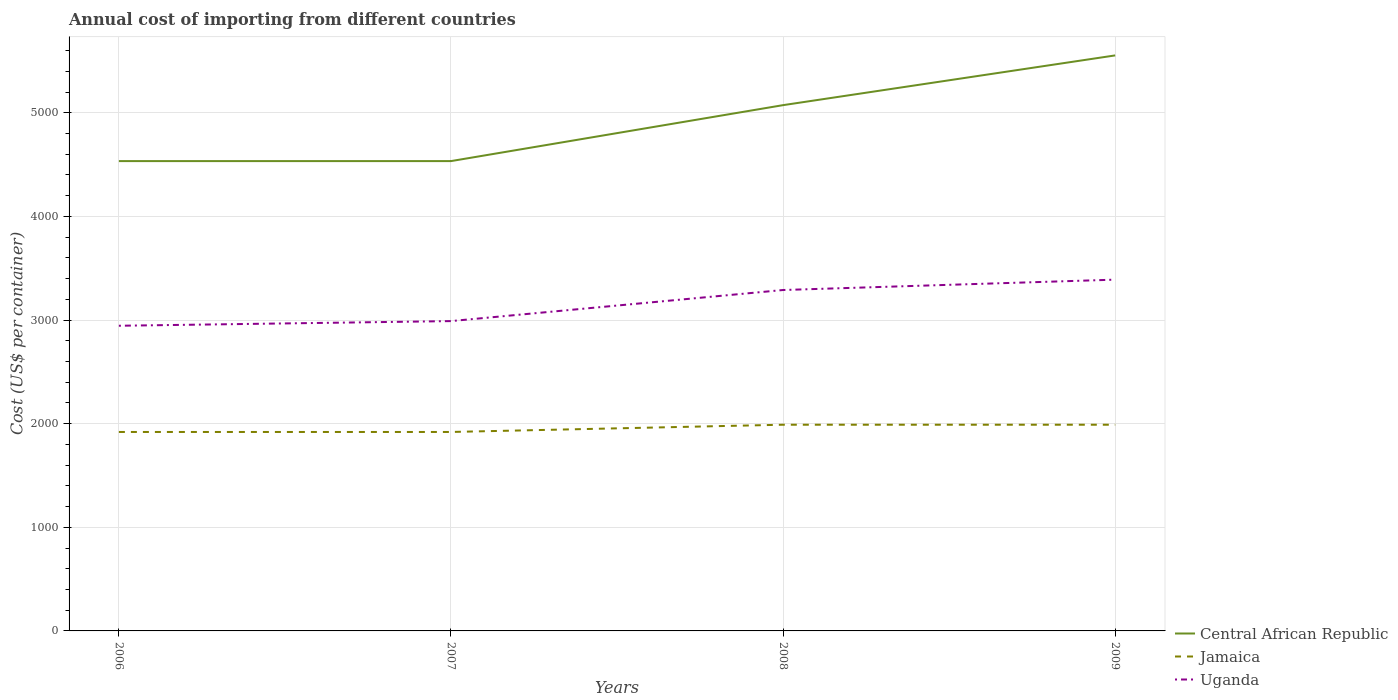Does the line corresponding to Central African Republic intersect with the line corresponding to Uganda?
Offer a terse response. No. Is the number of lines equal to the number of legend labels?
Give a very brief answer. Yes. Across all years, what is the maximum total annual cost of importing in Central African Republic?
Your answer should be very brief. 4534. What is the total total annual cost of importing in Jamaica in the graph?
Your answer should be compact. -70. What is the difference between the highest and the second highest total annual cost of importing in Uganda?
Your answer should be compact. 445. What is the difference between the highest and the lowest total annual cost of importing in Jamaica?
Offer a terse response. 2. Is the total annual cost of importing in Jamaica strictly greater than the total annual cost of importing in Uganda over the years?
Your answer should be compact. Yes. How many years are there in the graph?
Your response must be concise. 4. Does the graph contain grids?
Give a very brief answer. Yes. Where does the legend appear in the graph?
Provide a short and direct response. Bottom right. How many legend labels are there?
Make the answer very short. 3. What is the title of the graph?
Your response must be concise. Annual cost of importing from different countries. What is the label or title of the Y-axis?
Give a very brief answer. Cost (US$ per container). What is the Cost (US$ per container) of Central African Republic in 2006?
Give a very brief answer. 4534. What is the Cost (US$ per container) in Jamaica in 2006?
Give a very brief answer. 1920. What is the Cost (US$ per container) of Uganda in 2006?
Give a very brief answer. 2945. What is the Cost (US$ per container) of Central African Republic in 2007?
Give a very brief answer. 4534. What is the Cost (US$ per container) of Jamaica in 2007?
Your answer should be very brief. 1920. What is the Cost (US$ per container) in Uganda in 2007?
Keep it short and to the point. 2990. What is the Cost (US$ per container) of Central African Republic in 2008?
Keep it short and to the point. 5074. What is the Cost (US$ per container) of Jamaica in 2008?
Make the answer very short. 1990. What is the Cost (US$ per container) of Uganda in 2008?
Offer a terse response. 3290. What is the Cost (US$ per container) in Central African Republic in 2009?
Keep it short and to the point. 5554. What is the Cost (US$ per container) of Jamaica in 2009?
Offer a very short reply. 1990. What is the Cost (US$ per container) in Uganda in 2009?
Provide a short and direct response. 3390. Across all years, what is the maximum Cost (US$ per container) of Central African Republic?
Offer a terse response. 5554. Across all years, what is the maximum Cost (US$ per container) of Jamaica?
Your answer should be compact. 1990. Across all years, what is the maximum Cost (US$ per container) of Uganda?
Keep it short and to the point. 3390. Across all years, what is the minimum Cost (US$ per container) of Central African Republic?
Your response must be concise. 4534. Across all years, what is the minimum Cost (US$ per container) in Jamaica?
Provide a short and direct response. 1920. Across all years, what is the minimum Cost (US$ per container) of Uganda?
Offer a very short reply. 2945. What is the total Cost (US$ per container) in Central African Republic in the graph?
Your response must be concise. 1.97e+04. What is the total Cost (US$ per container) of Jamaica in the graph?
Offer a very short reply. 7820. What is the total Cost (US$ per container) of Uganda in the graph?
Make the answer very short. 1.26e+04. What is the difference between the Cost (US$ per container) of Jamaica in 2006 and that in 2007?
Offer a very short reply. 0. What is the difference between the Cost (US$ per container) in Uganda in 2006 and that in 2007?
Your answer should be compact. -45. What is the difference between the Cost (US$ per container) of Central African Republic in 2006 and that in 2008?
Your response must be concise. -540. What is the difference between the Cost (US$ per container) of Jamaica in 2006 and that in 2008?
Ensure brevity in your answer.  -70. What is the difference between the Cost (US$ per container) in Uganda in 2006 and that in 2008?
Your response must be concise. -345. What is the difference between the Cost (US$ per container) of Central African Republic in 2006 and that in 2009?
Give a very brief answer. -1020. What is the difference between the Cost (US$ per container) of Jamaica in 2006 and that in 2009?
Give a very brief answer. -70. What is the difference between the Cost (US$ per container) of Uganda in 2006 and that in 2009?
Provide a short and direct response. -445. What is the difference between the Cost (US$ per container) in Central African Republic in 2007 and that in 2008?
Give a very brief answer. -540. What is the difference between the Cost (US$ per container) in Jamaica in 2007 and that in 2008?
Your response must be concise. -70. What is the difference between the Cost (US$ per container) of Uganda in 2007 and that in 2008?
Provide a succinct answer. -300. What is the difference between the Cost (US$ per container) in Central African Republic in 2007 and that in 2009?
Give a very brief answer. -1020. What is the difference between the Cost (US$ per container) of Jamaica in 2007 and that in 2009?
Your answer should be very brief. -70. What is the difference between the Cost (US$ per container) in Uganda in 2007 and that in 2009?
Ensure brevity in your answer.  -400. What is the difference between the Cost (US$ per container) in Central African Republic in 2008 and that in 2009?
Ensure brevity in your answer.  -480. What is the difference between the Cost (US$ per container) in Jamaica in 2008 and that in 2009?
Your answer should be compact. 0. What is the difference between the Cost (US$ per container) in Uganda in 2008 and that in 2009?
Keep it short and to the point. -100. What is the difference between the Cost (US$ per container) of Central African Republic in 2006 and the Cost (US$ per container) of Jamaica in 2007?
Your answer should be very brief. 2614. What is the difference between the Cost (US$ per container) of Central African Republic in 2006 and the Cost (US$ per container) of Uganda in 2007?
Ensure brevity in your answer.  1544. What is the difference between the Cost (US$ per container) of Jamaica in 2006 and the Cost (US$ per container) of Uganda in 2007?
Your answer should be compact. -1070. What is the difference between the Cost (US$ per container) of Central African Republic in 2006 and the Cost (US$ per container) of Jamaica in 2008?
Provide a short and direct response. 2544. What is the difference between the Cost (US$ per container) of Central African Republic in 2006 and the Cost (US$ per container) of Uganda in 2008?
Your response must be concise. 1244. What is the difference between the Cost (US$ per container) in Jamaica in 2006 and the Cost (US$ per container) in Uganda in 2008?
Provide a short and direct response. -1370. What is the difference between the Cost (US$ per container) of Central African Republic in 2006 and the Cost (US$ per container) of Jamaica in 2009?
Provide a succinct answer. 2544. What is the difference between the Cost (US$ per container) in Central African Republic in 2006 and the Cost (US$ per container) in Uganda in 2009?
Offer a terse response. 1144. What is the difference between the Cost (US$ per container) in Jamaica in 2006 and the Cost (US$ per container) in Uganda in 2009?
Offer a very short reply. -1470. What is the difference between the Cost (US$ per container) of Central African Republic in 2007 and the Cost (US$ per container) of Jamaica in 2008?
Offer a terse response. 2544. What is the difference between the Cost (US$ per container) of Central African Republic in 2007 and the Cost (US$ per container) of Uganda in 2008?
Keep it short and to the point. 1244. What is the difference between the Cost (US$ per container) of Jamaica in 2007 and the Cost (US$ per container) of Uganda in 2008?
Keep it short and to the point. -1370. What is the difference between the Cost (US$ per container) of Central African Republic in 2007 and the Cost (US$ per container) of Jamaica in 2009?
Offer a very short reply. 2544. What is the difference between the Cost (US$ per container) of Central African Republic in 2007 and the Cost (US$ per container) of Uganda in 2009?
Keep it short and to the point. 1144. What is the difference between the Cost (US$ per container) of Jamaica in 2007 and the Cost (US$ per container) of Uganda in 2009?
Give a very brief answer. -1470. What is the difference between the Cost (US$ per container) of Central African Republic in 2008 and the Cost (US$ per container) of Jamaica in 2009?
Provide a succinct answer. 3084. What is the difference between the Cost (US$ per container) in Central African Republic in 2008 and the Cost (US$ per container) in Uganda in 2009?
Provide a short and direct response. 1684. What is the difference between the Cost (US$ per container) in Jamaica in 2008 and the Cost (US$ per container) in Uganda in 2009?
Ensure brevity in your answer.  -1400. What is the average Cost (US$ per container) of Central African Republic per year?
Your answer should be very brief. 4924. What is the average Cost (US$ per container) of Jamaica per year?
Keep it short and to the point. 1955. What is the average Cost (US$ per container) of Uganda per year?
Keep it short and to the point. 3153.75. In the year 2006, what is the difference between the Cost (US$ per container) in Central African Republic and Cost (US$ per container) in Jamaica?
Your answer should be very brief. 2614. In the year 2006, what is the difference between the Cost (US$ per container) of Central African Republic and Cost (US$ per container) of Uganda?
Provide a succinct answer. 1589. In the year 2006, what is the difference between the Cost (US$ per container) in Jamaica and Cost (US$ per container) in Uganda?
Make the answer very short. -1025. In the year 2007, what is the difference between the Cost (US$ per container) in Central African Republic and Cost (US$ per container) in Jamaica?
Give a very brief answer. 2614. In the year 2007, what is the difference between the Cost (US$ per container) of Central African Republic and Cost (US$ per container) of Uganda?
Your answer should be very brief. 1544. In the year 2007, what is the difference between the Cost (US$ per container) in Jamaica and Cost (US$ per container) in Uganda?
Provide a succinct answer. -1070. In the year 2008, what is the difference between the Cost (US$ per container) of Central African Republic and Cost (US$ per container) of Jamaica?
Your response must be concise. 3084. In the year 2008, what is the difference between the Cost (US$ per container) of Central African Republic and Cost (US$ per container) of Uganda?
Provide a short and direct response. 1784. In the year 2008, what is the difference between the Cost (US$ per container) in Jamaica and Cost (US$ per container) in Uganda?
Offer a terse response. -1300. In the year 2009, what is the difference between the Cost (US$ per container) of Central African Republic and Cost (US$ per container) of Jamaica?
Your answer should be compact. 3564. In the year 2009, what is the difference between the Cost (US$ per container) of Central African Republic and Cost (US$ per container) of Uganda?
Your answer should be compact. 2164. In the year 2009, what is the difference between the Cost (US$ per container) of Jamaica and Cost (US$ per container) of Uganda?
Make the answer very short. -1400. What is the ratio of the Cost (US$ per container) in Central African Republic in 2006 to that in 2007?
Give a very brief answer. 1. What is the ratio of the Cost (US$ per container) in Uganda in 2006 to that in 2007?
Provide a succinct answer. 0.98. What is the ratio of the Cost (US$ per container) in Central African Republic in 2006 to that in 2008?
Ensure brevity in your answer.  0.89. What is the ratio of the Cost (US$ per container) of Jamaica in 2006 to that in 2008?
Offer a terse response. 0.96. What is the ratio of the Cost (US$ per container) of Uganda in 2006 to that in 2008?
Make the answer very short. 0.9. What is the ratio of the Cost (US$ per container) of Central African Republic in 2006 to that in 2009?
Keep it short and to the point. 0.82. What is the ratio of the Cost (US$ per container) of Jamaica in 2006 to that in 2009?
Provide a succinct answer. 0.96. What is the ratio of the Cost (US$ per container) in Uganda in 2006 to that in 2009?
Your answer should be compact. 0.87. What is the ratio of the Cost (US$ per container) of Central African Republic in 2007 to that in 2008?
Offer a very short reply. 0.89. What is the ratio of the Cost (US$ per container) in Jamaica in 2007 to that in 2008?
Keep it short and to the point. 0.96. What is the ratio of the Cost (US$ per container) in Uganda in 2007 to that in 2008?
Your answer should be very brief. 0.91. What is the ratio of the Cost (US$ per container) in Central African Republic in 2007 to that in 2009?
Keep it short and to the point. 0.82. What is the ratio of the Cost (US$ per container) in Jamaica in 2007 to that in 2009?
Offer a terse response. 0.96. What is the ratio of the Cost (US$ per container) in Uganda in 2007 to that in 2009?
Your answer should be very brief. 0.88. What is the ratio of the Cost (US$ per container) in Central African Republic in 2008 to that in 2009?
Offer a terse response. 0.91. What is the ratio of the Cost (US$ per container) in Uganda in 2008 to that in 2009?
Keep it short and to the point. 0.97. What is the difference between the highest and the second highest Cost (US$ per container) of Central African Republic?
Give a very brief answer. 480. What is the difference between the highest and the second highest Cost (US$ per container) of Jamaica?
Provide a short and direct response. 0. What is the difference between the highest and the second highest Cost (US$ per container) in Uganda?
Keep it short and to the point. 100. What is the difference between the highest and the lowest Cost (US$ per container) in Central African Republic?
Keep it short and to the point. 1020. What is the difference between the highest and the lowest Cost (US$ per container) of Jamaica?
Ensure brevity in your answer.  70. What is the difference between the highest and the lowest Cost (US$ per container) of Uganda?
Your answer should be very brief. 445. 